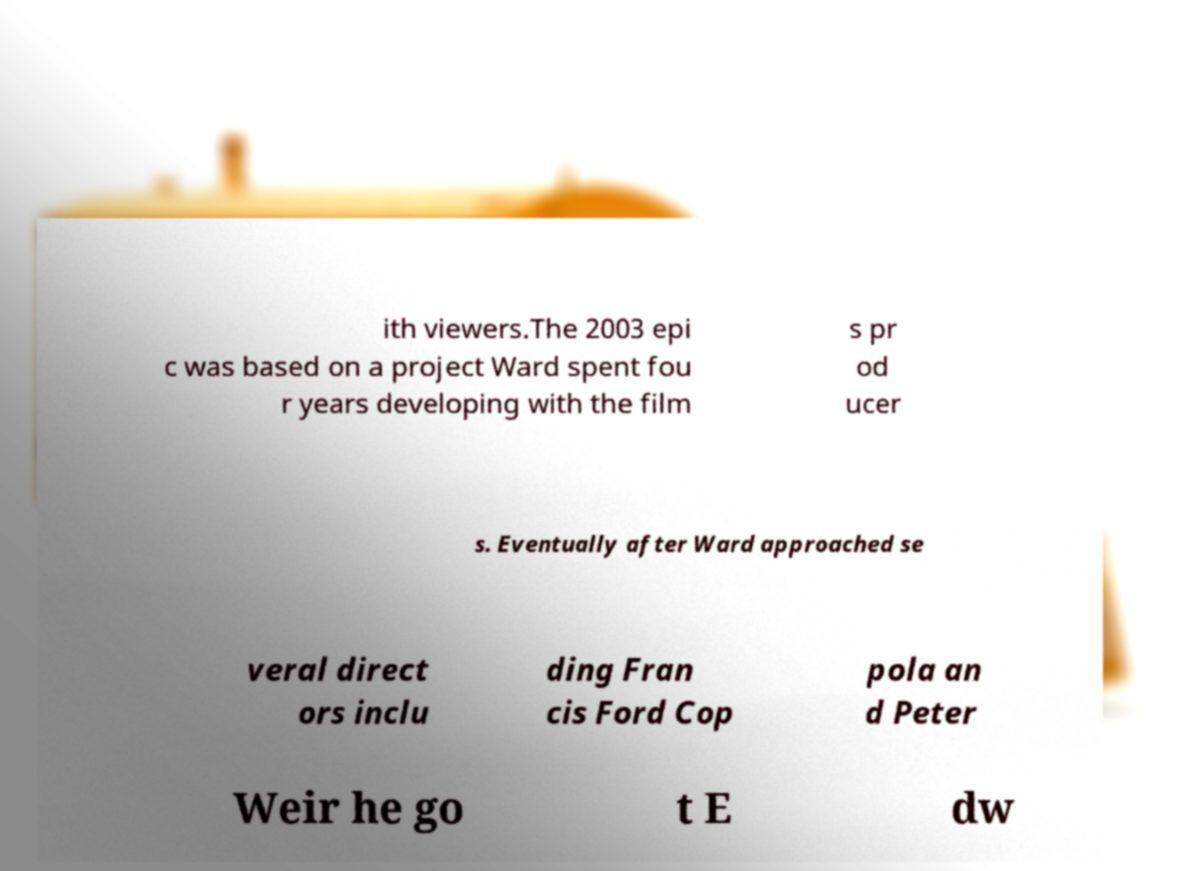For documentation purposes, I need the text within this image transcribed. Could you provide that? ith viewers.The 2003 epi c was based on a project Ward spent fou r years developing with the film s pr od ucer s. Eventually after Ward approached se veral direct ors inclu ding Fran cis Ford Cop pola an d Peter Weir he go t E dw 